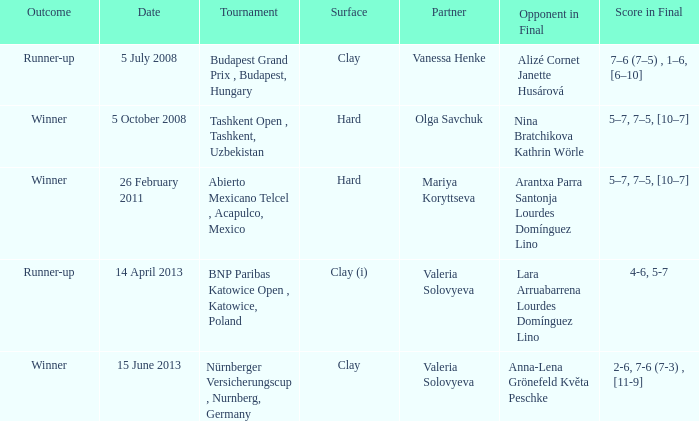Which partner was on 14 april 2013? Valeria Solovyeva. 